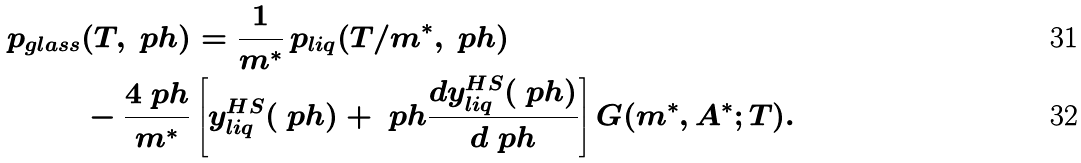<formula> <loc_0><loc_0><loc_500><loc_500>p _ { g l a s s } & ( T , \ p h ) = \frac { 1 } { m ^ { * } } \, p _ { l i q } ( T / m ^ { * } , \ p h ) \\ & - \frac { 4 \ p h } { m ^ { * } } \left [ y ^ { H S } _ { l i q } ( \ p h ) + \ p h \frac { d y ^ { H S } _ { l i q } ( \ p h ) } { d \ p h } \right ] G ( m ^ { * } , A ^ { * } ; T ) .</formula> 